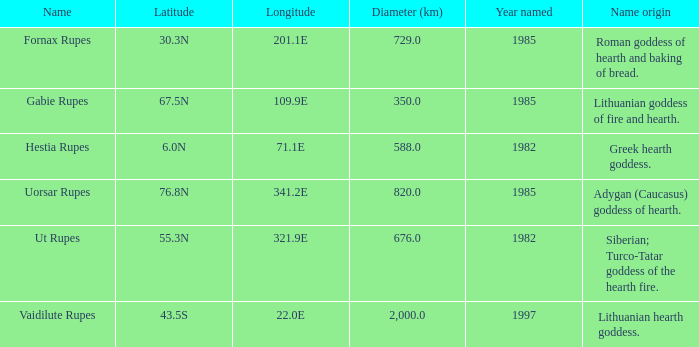At a longitude of 10 1.0. Could you parse the entire table? {'header': ['Name', 'Latitude', 'Longitude', 'Diameter (km)', 'Year named', 'Name origin'], 'rows': [['Fornax Rupes', '30.3N', '201.1E', '729.0', '1985', 'Roman goddess of hearth and baking of bread.'], ['Gabie Rupes', '67.5N', '109.9E', '350.0', '1985', 'Lithuanian goddess of fire and hearth.'], ['Hestia Rupes', '6.0N', '71.1E', '588.0', '1982', 'Greek hearth goddess.'], ['Uorsar Rupes', '76.8N', '341.2E', '820.0', '1985', 'Adygan (Caucasus) goddess of hearth.'], ['Ut Rupes', '55.3N', '321.9E', '676.0', '1982', 'Siberian; Turco-Tatar goddess of the hearth fire.'], ['Vaidilute Rupes', '43.5S', '22.0E', '2,000.0', '1997', 'Lithuanian hearth goddess.']]} 